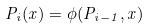Convert formula to latex. <formula><loc_0><loc_0><loc_500><loc_500>P _ { i } ( x ) = \phi ( P _ { i - 1 } , x )</formula> 